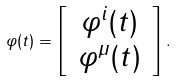<formula> <loc_0><loc_0><loc_500><loc_500>\varphi ( t ) = \left [ \begin{array} { c } \, \varphi ^ { i } ( t ) \, \\ \varphi ^ { \mu } ( t ) \end{array} \right ] .</formula> 